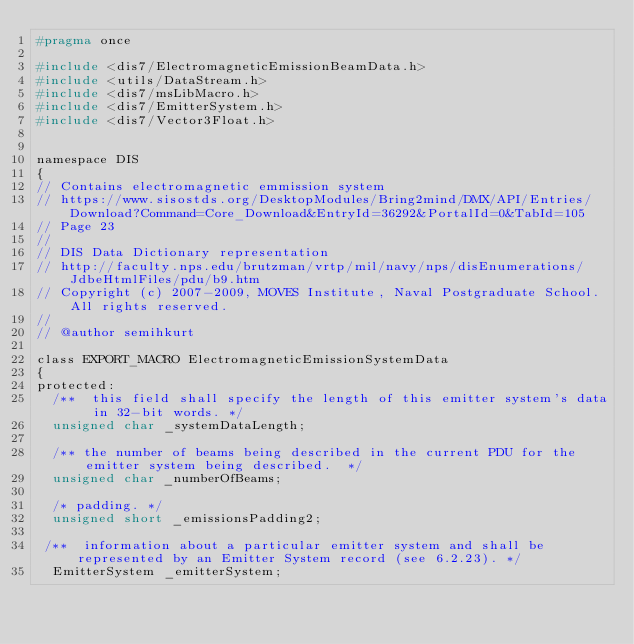<code> <loc_0><loc_0><loc_500><loc_500><_C_>#pragma once

#include <dis7/ElectromagneticEmissionBeamData.h>
#include <utils/DataStream.h>
#include <dis7/msLibMacro.h>
#include <dis7/EmitterSystem.h>
#include <dis7/Vector3Float.h>


namespace DIS
{
// Contains electromagnetic emmission system
// https://www.sisostds.org/DesktopModules/Bring2mind/DMX/API/Entries/Download?Command=Core_Download&EntryId=36292&PortalId=0&TabId=105
// Page 23
// 
// DIS Data Dictionary representation
// http://faculty.nps.edu/brutzman/vrtp/mil/navy/nps/disEnumerations/JdbeHtmlFiles/pdu/b9.htm
// Copyright (c) 2007-2009, MOVES Institute, Naval Postgraduate School. All rights reserved. 
//
// @author semihkurt

class EXPORT_MACRO ElectromagneticEmissionSystemData
{
protected:
  /**  this field shall specify the length of this emitter system's data in 32-bit words. */
  unsigned char _systemDataLength;

  /** the number of beams being described in the current PDU for the emitter system being described.  */
  unsigned char _numberOfBeams;

  /* padding. */
  unsigned short _emissionsPadding2;

 /**  information about a particular emitter system and shall be represented by an Emitter System record (see 6.2.23). */
  EmitterSystem _emitterSystem; 
</code> 